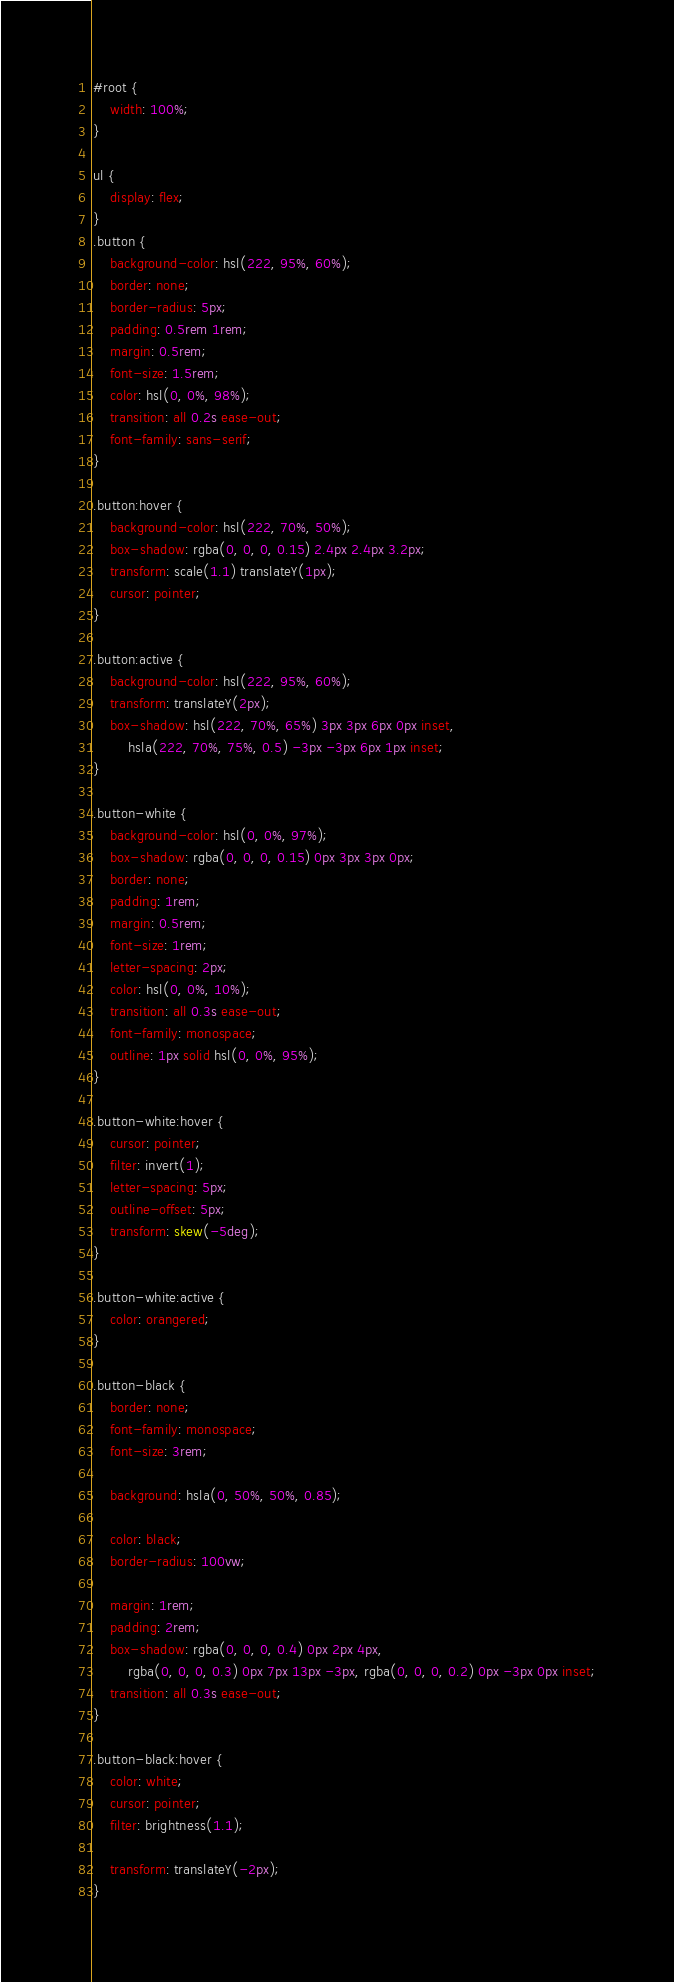Convert code to text. <code><loc_0><loc_0><loc_500><loc_500><_CSS_>#root {
	width: 100%;
}

ul {
	display: flex;
}
.button {
	background-color: hsl(222, 95%, 60%);
	border: none;
	border-radius: 5px;
	padding: 0.5rem 1rem;
	margin: 0.5rem;
	font-size: 1.5rem;
	color: hsl(0, 0%, 98%);
	transition: all 0.2s ease-out;
	font-family: sans-serif;
}

.button:hover {
	background-color: hsl(222, 70%, 50%);
	box-shadow: rgba(0, 0, 0, 0.15) 2.4px 2.4px 3.2px;
	transform: scale(1.1) translateY(1px);
	cursor: pointer;
}

.button:active {
	background-color: hsl(222, 95%, 60%);
	transform: translateY(2px);
	box-shadow: hsl(222, 70%, 65%) 3px 3px 6px 0px inset,
		hsla(222, 70%, 75%, 0.5) -3px -3px 6px 1px inset;
}

.button-white {
	background-color: hsl(0, 0%, 97%);
	box-shadow: rgba(0, 0, 0, 0.15) 0px 3px 3px 0px;
	border: none;
	padding: 1rem;
	margin: 0.5rem;
	font-size: 1rem;
	letter-spacing: 2px;
	color: hsl(0, 0%, 10%);
	transition: all 0.3s ease-out;
	font-family: monospace;
	outline: 1px solid hsl(0, 0%, 95%);
}

.button-white:hover {
	cursor: pointer;
	filter: invert(1);
	letter-spacing: 5px;
	outline-offset: 5px;
	transform: skew(-5deg);
}

.button-white:active {
	color: orangered;
}

.button-black {
	border: none;
	font-family: monospace;
	font-size: 3rem;

	background: hsla(0, 50%, 50%, 0.85);

	color: black;
	border-radius: 100vw;

	margin: 1rem;
	padding: 2rem;
	box-shadow: rgba(0, 0, 0, 0.4) 0px 2px 4px,
		rgba(0, 0, 0, 0.3) 0px 7px 13px -3px, rgba(0, 0, 0, 0.2) 0px -3px 0px inset;
	transition: all 0.3s ease-out;
}

.button-black:hover {
	color: white;
	cursor: pointer;
	filter: brightness(1.1);

	transform: translateY(-2px);
}
</code> 